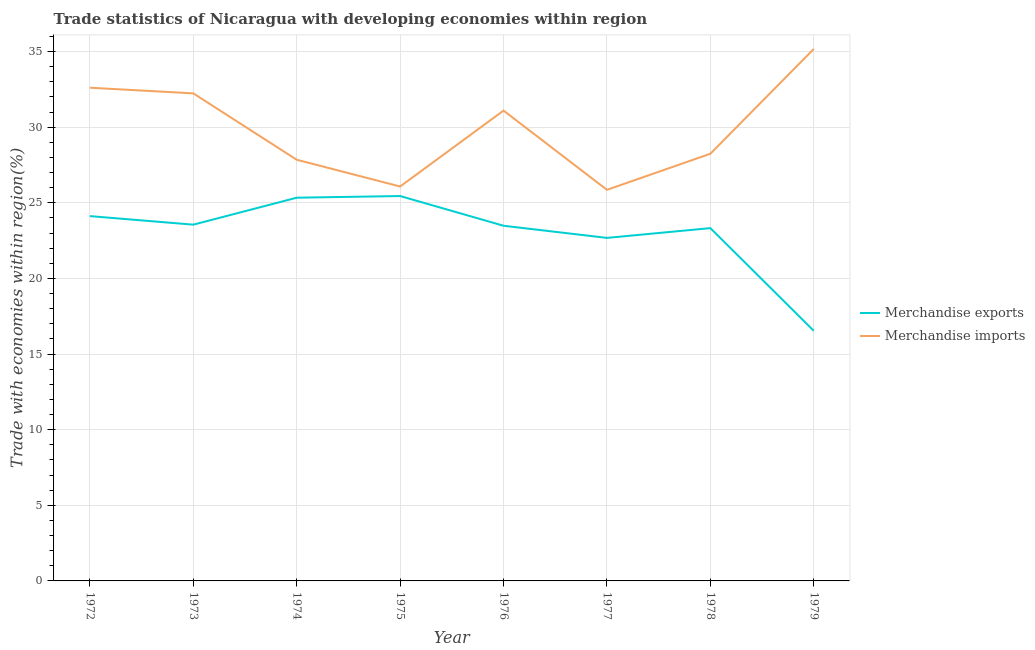Does the line corresponding to merchandise exports intersect with the line corresponding to merchandise imports?
Make the answer very short. No. Is the number of lines equal to the number of legend labels?
Your response must be concise. Yes. What is the merchandise imports in 1977?
Provide a succinct answer. 25.86. Across all years, what is the maximum merchandise imports?
Provide a succinct answer. 35.18. Across all years, what is the minimum merchandise imports?
Offer a terse response. 25.86. In which year was the merchandise imports maximum?
Your answer should be compact. 1979. In which year was the merchandise imports minimum?
Keep it short and to the point. 1977. What is the total merchandise exports in the graph?
Make the answer very short. 184.51. What is the difference between the merchandise exports in 1972 and that in 1976?
Provide a succinct answer. 0.64. What is the difference between the merchandise exports in 1972 and the merchandise imports in 1973?
Your answer should be very brief. -8.12. What is the average merchandise imports per year?
Offer a terse response. 29.9. In the year 1979, what is the difference between the merchandise exports and merchandise imports?
Make the answer very short. -18.64. What is the ratio of the merchandise imports in 1973 to that in 1976?
Offer a terse response. 1.04. What is the difference between the highest and the second highest merchandise imports?
Make the answer very short. 2.56. What is the difference between the highest and the lowest merchandise imports?
Give a very brief answer. 9.31. In how many years, is the merchandise imports greater than the average merchandise imports taken over all years?
Offer a very short reply. 4. Is the sum of the merchandise imports in 1973 and 1979 greater than the maximum merchandise exports across all years?
Keep it short and to the point. Yes. Does the merchandise imports monotonically increase over the years?
Your answer should be very brief. No. Is the merchandise exports strictly greater than the merchandise imports over the years?
Offer a very short reply. No. Are the values on the major ticks of Y-axis written in scientific E-notation?
Make the answer very short. No. Does the graph contain any zero values?
Provide a short and direct response. No. How many legend labels are there?
Give a very brief answer. 2. How are the legend labels stacked?
Keep it short and to the point. Vertical. What is the title of the graph?
Your response must be concise. Trade statistics of Nicaragua with developing economies within region. Does "GDP" appear as one of the legend labels in the graph?
Your answer should be compact. No. What is the label or title of the X-axis?
Offer a very short reply. Year. What is the label or title of the Y-axis?
Provide a succinct answer. Trade with economies within region(%). What is the Trade with economies within region(%) of Merchandise exports in 1972?
Your response must be concise. 24.12. What is the Trade with economies within region(%) of Merchandise imports in 1972?
Give a very brief answer. 32.61. What is the Trade with economies within region(%) of Merchandise exports in 1973?
Provide a succinct answer. 23.56. What is the Trade with economies within region(%) of Merchandise imports in 1973?
Provide a short and direct response. 32.24. What is the Trade with economies within region(%) of Merchandise exports in 1974?
Your response must be concise. 25.34. What is the Trade with economies within region(%) of Merchandise imports in 1974?
Provide a short and direct response. 27.85. What is the Trade with economies within region(%) of Merchandise exports in 1975?
Offer a terse response. 25.45. What is the Trade with economies within region(%) of Merchandise imports in 1975?
Provide a short and direct response. 26.08. What is the Trade with economies within region(%) in Merchandise exports in 1976?
Ensure brevity in your answer.  23.49. What is the Trade with economies within region(%) of Merchandise imports in 1976?
Give a very brief answer. 31.1. What is the Trade with economies within region(%) of Merchandise exports in 1977?
Make the answer very short. 22.68. What is the Trade with economies within region(%) in Merchandise imports in 1977?
Give a very brief answer. 25.86. What is the Trade with economies within region(%) of Merchandise exports in 1978?
Your answer should be very brief. 23.33. What is the Trade with economies within region(%) in Merchandise imports in 1978?
Ensure brevity in your answer.  28.25. What is the Trade with economies within region(%) of Merchandise exports in 1979?
Your answer should be very brief. 16.54. What is the Trade with economies within region(%) of Merchandise imports in 1979?
Ensure brevity in your answer.  35.18. Across all years, what is the maximum Trade with economies within region(%) of Merchandise exports?
Provide a succinct answer. 25.45. Across all years, what is the maximum Trade with economies within region(%) in Merchandise imports?
Ensure brevity in your answer.  35.18. Across all years, what is the minimum Trade with economies within region(%) of Merchandise exports?
Provide a succinct answer. 16.54. Across all years, what is the minimum Trade with economies within region(%) of Merchandise imports?
Offer a terse response. 25.86. What is the total Trade with economies within region(%) of Merchandise exports in the graph?
Your answer should be very brief. 184.51. What is the total Trade with economies within region(%) in Merchandise imports in the graph?
Provide a short and direct response. 239.17. What is the difference between the Trade with economies within region(%) of Merchandise exports in 1972 and that in 1973?
Offer a very short reply. 0.56. What is the difference between the Trade with economies within region(%) in Merchandise imports in 1972 and that in 1973?
Provide a succinct answer. 0.37. What is the difference between the Trade with economies within region(%) of Merchandise exports in 1972 and that in 1974?
Your answer should be compact. -1.22. What is the difference between the Trade with economies within region(%) of Merchandise imports in 1972 and that in 1974?
Keep it short and to the point. 4.76. What is the difference between the Trade with economies within region(%) of Merchandise exports in 1972 and that in 1975?
Your answer should be compact. -1.33. What is the difference between the Trade with economies within region(%) of Merchandise imports in 1972 and that in 1975?
Keep it short and to the point. 6.53. What is the difference between the Trade with economies within region(%) in Merchandise exports in 1972 and that in 1976?
Provide a succinct answer. 0.64. What is the difference between the Trade with economies within region(%) of Merchandise imports in 1972 and that in 1976?
Keep it short and to the point. 1.51. What is the difference between the Trade with economies within region(%) of Merchandise exports in 1972 and that in 1977?
Your answer should be compact. 1.44. What is the difference between the Trade with economies within region(%) of Merchandise imports in 1972 and that in 1977?
Make the answer very short. 6.75. What is the difference between the Trade with economies within region(%) in Merchandise exports in 1972 and that in 1978?
Provide a short and direct response. 0.79. What is the difference between the Trade with economies within region(%) of Merchandise imports in 1972 and that in 1978?
Your answer should be compact. 4.37. What is the difference between the Trade with economies within region(%) of Merchandise exports in 1972 and that in 1979?
Offer a terse response. 7.58. What is the difference between the Trade with economies within region(%) of Merchandise imports in 1972 and that in 1979?
Provide a short and direct response. -2.56. What is the difference between the Trade with economies within region(%) of Merchandise exports in 1973 and that in 1974?
Make the answer very short. -1.78. What is the difference between the Trade with economies within region(%) of Merchandise imports in 1973 and that in 1974?
Provide a short and direct response. 4.39. What is the difference between the Trade with economies within region(%) of Merchandise exports in 1973 and that in 1975?
Provide a short and direct response. -1.89. What is the difference between the Trade with economies within region(%) of Merchandise imports in 1973 and that in 1975?
Give a very brief answer. 6.16. What is the difference between the Trade with economies within region(%) of Merchandise exports in 1973 and that in 1976?
Provide a short and direct response. 0.07. What is the difference between the Trade with economies within region(%) of Merchandise imports in 1973 and that in 1976?
Make the answer very short. 1.14. What is the difference between the Trade with economies within region(%) in Merchandise exports in 1973 and that in 1977?
Keep it short and to the point. 0.88. What is the difference between the Trade with economies within region(%) of Merchandise imports in 1973 and that in 1977?
Provide a short and direct response. 6.38. What is the difference between the Trade with economies within region(%) of Merchandise exports in 1973 and that in 1978?
Provide a succinct answer. 0.23. What is the difference between the Trade with economies within region(%) of Merchandise imports in 1973 and that in 1978?
Give a very brief answer. 3.99. What is the difference between the Trade with economies within region(%) of Merchandise exports in 1973 and that in 1979?
Your answer should be compact. 7.02. What is the difference between the Trade with economies within region(%) of Merchandise imports in 1973 and that in 1979?
Keep it short and to the point. -2.94. What is the difference between the Trade with economies within region(%) in Merchandise exports in 1974 and that in 1975?
Keep it short and to the point. -0.11. What is the difference between the Trade with economies within region(%) in Merchandise imports in 1974 and that in 1975?
Give a very brief answer. 1.77. What is the difference between the Trade with economies within region(%) of Merchandise exports in 1974 and that in 1976?
Provide a short and direct response. 1.85. What is the difference between the Trade with economies within region(%) in Merchandise imports in 1974 and that in 1976?
Offer a very short reply. -3.25. What is the difference between the Trade with economies within region(%) in Merchandise exports in 1974 and that in 1977?
Your answer should be very brief. 2.66. What is the difference between the Trade with economies within region(%) in Merchandise imports in 1974 and that in 1977?
Offer a very short reply. 1.99. What is the difference between the Trade with economies within region(%) in Merchandise exports in 1974 and that in 1978?
Ensure brevity in your answer.  2.01. What is the difference between the Trade with economies within region(%) of Merchandise imports in 1974 and that in 1978?
Offer a terse response. -0.4. What is the difference between the Trade with economies within region(%) in Merchandise exports in 1974 and that in 1979?
Ensure brevity in your answer.  8.8. What is the difference between the Trade with economies within region(%) in Merchandise imports in 1974 and that in 1979?
Provide a succinct answer. -7.33. What is the difference between the Trade with economies within region(%) of Merchandise exports in 1975 and that in 1976?
Your answer should be compact. 1.96. What is the difference between the Trade with economies within region(%) in Merchandise imports in 1975 and that in 1976?
Provide a short and direct response. -5.02. What is the difference between the Trade with economies within region(%) of Merchandise exports in 1975 and that in 1977?
Your answer should be very brief. 2.77. What is the difference between the Trade with economies within region(%) in Merchandise imports in 1975 and that in 1977?
Your answer should be very brief. 0.22. What is the difference between the Trade with economies within region(%) in Merchandise exports in 1975 and that in 1978?
Your answer should be very brief. 2.12. What is the difference between the Trade with economies within region(%) of Merchandise imports in 1975 and that in 1978?
Provide a short and direct response. -2.17. What is the difference between the Trade with economies within region(%) of Merchandise exports in 1975 and that in 1979?
Offer a very short reply. 8.91. What is the difference between the Trade with economies within region(%) in Merchandise imports in 1975 and that in 1979?
Make the answer very short. -9.09. What is the difference between the Trade with economies within region(%) of Merchandise exports in 1976 and that in 1977?
Make the answer very short. 0.8. What is the difference between the Trade with economies within region(%) in Merchandise imports in 1976 and that in 1977?
Give a very brief answer. 5.24. What is the difference between the Trade with economies within region(%) in Merchandise exports in 1976 and that in 1978?
Offer a terse response. 0.16. What is the difference between the Trade with economies within region(%) in Merchandise imports in 1976 and that in 1978?
Offer a very short reply. 2.85. What is the difference between the Trade with economies within region(%) of Merchandise exports in 1976 and that in 1979?
Ensure brevity in your answer.  6.95. What is the difference between the Trade with economies within region(%) of Merchandise imports in 1976 and that in 1979?
Give a very brief answer. -4.08. What is the difference between the Trade with economies within region(%) in Merchandise exports in 1977 and that in 1978?
Keep it short and to the point. -0.65. What is the difference between the Trade with economies within region(%) in Merchandise imports in 1977 and that in 1978?
Offer a very short reply. -2.39. What is the difference between the Trade with economies within region(%) in Merchandise exports in 1977 and that in 1979?
Provide a succinct answer. 6.14. What is the difference between the Trade with economies within region(%) in Merchandise imports in 1977 and that in 1979?
Give a very brief answer. -9.31. What is the difference between the Trade with economies within region(%) of Merchandise exports in 1978 and that in 1979?
Give a very brief answer. 6.79. What is the difference between the Trade with economies within region(%) of Merchandise imports in 1978 and that in 1979?
Your answer should be very brief. -6.93. What is the difference between the Trade with economies within region(%) in Merchandise exports in 1972 and the Trade with economies within region(%) in Merchandise imports in 1973?
Your response must be concise. -8.12. What is the difference between the Trade with economies within region(%) of Merchandise exports in 1972 and the Trade with economies within region(%) of Merchandise imports in 1974?
Your answer should be compact. -3.73. What is the difference between the Trade with economies within region(%) of Merchandise exports in 1972 and the Trade with economies within region(%) of Merchandise imports in 1975?
Make the answer very short. -1.96. What is the difference between the Trade with economies within region(%) of Merchandise exports in 1972 and the Trade with economies within region(%) of Merchandise imports in 1976?
Provide a succinct answer. -6.98. What is the difference between the Trade with economies within region(%) of Merchandise exports in 1972 and the Trade with economies within region(%) of Merchandise imports in 1977?
Your answer should be compact. -1.74. What is the difference between the Trade with economies within region(%) in Merchandise exports in 1972 and the Trade with economies within region(%) in Merchandise imports in 1978?
Your response must be concise. -4.12. What is the difference between the Trade with economies within region(%) of Merchandise exports in 1972 and the Trade with economies within region(%) of Merchandise imports in 1979?
Provide a short and direct response. -11.05. What is the difference between the Trade with economies within region(%) of Merchandise exports in 1973 and the Trade with economies within region(%) of Merchandise imports in 1974?
Provide a succinct answer. -4.29. What is the difference between the Trade with economies within region(%) of Merchandise exports in 1973 and the Trade with economies within region(%) of Merchandise imports in 1975?
Your response must be concise. -2.52. What is the difference between the Trade with economies within region(%) of Merchandise exports in 1973 and the Trade with economies within region(%) of Merchandise imports in 1976?
Provide a succinct answer. -7.54. What is the difference between the Trade with economies within region(%) in Merchandise exports in 1973 and the Trade with economies within region(%) in Merchandise imports in 1977?
Provide a short and direct response. -2.3. What is the difference between the Trade with economies within region(%) of Merchandise exports in 1973 and the Trade with economies within region(%) of Merchandise imports in 1978?
Your answer should be compact. -4.69. What is the difference between the Trade with economies within region(%) of Merchandise exports in 1973 and the Trade with economies within region(%) of Merchandise imports in 1979?
Provide a succinct answer. -11.62. What is the difference between the Trade with economies within region(%) of Merchandise exports in 1974 and the Trade with economies within region(%) of Merchandise imports in 1975?
Your answer should be compact. -0.74. What is the difference between the Trade with economies within region(%) of Merchandise exports in 1974 and the Trade with economies within region(%) of Merchandise imports in 1976?
Provide a succinct answer. -5.76. What is the difference between the Trade with economies within region(%) in Merchandise exports in 1974 and the Trade with economies within region(%) in Merchandise imports in 1977?
Make the answer very short. -0.52. What is the difference between the Trade with economies within region(%) in Merchandise exports in 1974 and the Trade with economies within region(%) in Merchandise imports in 1978?
Offer a terse response. -2.91. What is the difference between the Trade with economies within region(%) of Merchandise exports in 1974 and the Trade with economies within region(%) of Merchandise imports in 1979?
Ensure brevity in your answer.  -9.84. What is the difference between the Trade with economies within region(%) of Merchandise exports in 1975 and the Trade with economies within region(%) of Merchandise imports in 1976?
Your answer should be compact. -5.65. What is the difference between the Trade with economies within region(%) of Merchandise exports in 1975 and the Trade with economies within region(%) of Merchandise imports in 1977?
Your answer should be compact. -0.41. What is the difference between the Trade with economies within region(%) of Merchandise exports in 1975 and the Trade with economies within region(%) of Merchandise imports in 1978?
Ensure brevity in your answer.  -2.8. What is the difference between the Trade with economies within region(%) in Merchandise exports in 1975 and the Trade with economies within region(%) in Merchandise imports in 1979?
Ensure brevity in your answer.  -9.72. What is the difference between the Trade with economies within region(%) of Merchandise exports in 1976 and the Trade with economies within region(%) of Merchandise imports in 1977?
Provide a succinct answer. -2.38. What is the difference between the Trade with economies within region(%) of Merchandise exports in 1976 and the Trade with economies within region(%) of Merchandise imports in 1978?
Your response must be concise. -4.76. What is the difference between the Trade with economies within region(%) of Merchandise exports in 1976 and the Trade with economies within region(%) of Merchandise imports in 1979?
Provide a succinct answer. -11.69. What is the difference between the Trade with economies within region(%) of Merchandise exports in 1977 and the Trade with economies within region(%) of Merchandise imports in 1978?
Keep it short and to the point. -5.56. What is the difference between the Trade with economies within region(%) in Merchandise exports in 1977 and the Trade with economies within region(%) in Merchandise imports in 1979?
Provide a short and direct response. -12.49. What is the difference between the Trade with economies within region(%) of Merchandise exports in 1978 and the Trade with economies within region(%) of Merchandise imports in 1979?
Keep it short and to the point. -11.85. What is the average Trade with economies within region(%) in Merchandise exports per year?
Keep it short and to the point. 23.06. What is the average Trade with economies within region(%) in Merchandise imports per year?
Provide a succinct answer. 29.9. In the year 1972, what is the difference between the Trade with economies within region(%) of Merchandise exports and Trade with economies within region(%) of Merchandise imports?
Keep it short and to the point. -8.49. In the year 1973, what is the difference between the Trade with economies within region(%) in Merchandise exports and Trade with economies within region(%) in Merchandise imports?
Make the answer very short. -8.68. In the year 1974, what is the difference between the Trade with economies within region(%) in Merchandise exports and Trade with economies within region(%) in Merchandise imports?
Your answer should be compact. -2.51. In the year 1975, what is the difference between the Trade with economies within region(%) of Merchandise exports and Trade with economies within region(%) of Merchandise imports?
Ensure brevity in your answer.  -0.63. In the year 1976, what is the difference between the Trade with economies within region(%) in Merchandise exports and Trade with economies within region(%) in Merchandise imports?
Provide a succinct answer. -7.61. In the year 1977, what is the difference between the Trade with economies within region(%) in Merchandise exports and Trade with economies within region(%) in Merchandise imports?
Keep it short and to the point. -3.18. In the year 1978, what is the difference between the Trade with economies within region(%) in Merchandise exports and Trade with economies within region(%) in Merchandise imports?
Ensure brevity in your answer.  -4.92. In the year 1979, what is the difference between the Trade with economies within region(%) in Merchandise exports and Trade with economies within region(%) in Merchandise imports?
Offer a very short reply. -18.64. What is the ratio of the Trade with economies within region(%) in Merchandise imports in 1972 to that in 1973?
Offer a terse response. 1.01. What is the ratio of the Trade with economies within region(%) in Merchandise exports in 1972 to that in 1974?
Your answer should be very brief. 0.95. What is the ratio of the Trade with economies within region(%) in Merchandise imports in 1972 to that in 1974?
Offer a terse response. 1.17. What is the ratio of the Trade with economies within region(%) in Merchandise exports in 1972 to that in 1975?
Keep it short and to the point. 0.95. What is the ratio of the Trade with economies within region(%) of Merchandise imports in 1972 to that in 1975?
Offer a terse response. 1.25. What is the ratio of the Trade with economies within region(%) in Merchandise exports in 1972 to that in 1976?
Give a very brief answer. 1.03. What is the ratio of the Trade with economies within region(%) in Merchandise imports in 1972 to that in 1976?
Offer a very short reply. 1.05. What is the ratio of the Trade with economies within region(%) of Merchandise exports in 1972 to that in 1977?
Provide a succinct answer. 1.06. What is the ratio of the Trade with economies within region(%) in Merchandise imports in 1972 to that in 1977?
Your answer should be very brief. 1.26. What is the ratio of the Trade with economies within region(%) in Merchandise exports in 1972 to that in 1978?
Your answer should be compact. 1.03. What is the ratio of the Trade with economies within region(%) in Merchandise imports in 1972 to that in 1978?
Offer a terse response. 1.15. What is the ratio of the Trade with economies within region(%) in Merchandise exports in 1972 to that in 1979?
Offer a very short reply. 1.46. What is the ratio of the Trade with economies within region(%) in Merchandise imports in 1972 to that in 1979?
Make the answer very short. 0.93. What is the ratio of the Trade with economies within region(%) of Merchandise exports in 1973 to that in 1974?
Ensure brevity in your answer.  0.93. What is the ratio of the Trade with economies within region(%) in Merchandise imports in 1973 to that in 1974?
Your answer should be very brief. 1.16. What is the ratio of the Trade with economies within region(%) in Merchandise exports in 1973 to that in 1975?
Offer a very short reply. 0.93. What is the ratio of the Trade with economies within region(%) of Merchandise imports in 1973 to that in 1975?
Provide a short and direct response. 1.24. What is the ratio of the Trade with economies within region(%) in Merchandise imports in 1973 to that in 1976?
Offer a very short reply. 1.04. What is the ratio of the Trade with economies within region(%) of Merchandise exports in 1973 to that in 1977?
Make the answer very short. 1.04. What is the ratio of the Trade with economies within region(%) in Merchandise imports in 1973 to that in 1977?
Offer a very short reply. 1.25. What is the ratio of the Trade with economies within region(%) of Merchandise exports in 1973 to that in 1978?
Offer a very short reply. 1.01. What is the ratio of the Trade with economies within region(%) in Merchandise imports in 1973 to that in 1978?
Give a very brief answer. 1.14. What is the ratio of the Trade with economies within region(%) in Merchandise exports in 1973 to that in 1979?
Provide a short and direct response. 1.42. What is the ratio of the Trade with economies within region(%) in Merchandise imports in 1973 to that in 1979?
Offer a terse response. 0.92. What is the ratio of the Trade with economies within region(%) of Merchandise exports in 1974 to that in 1975?
Keep it short and to the point. 1. What is the ratio of the Trade with economies within region(%) of Merchandise imports in 1974 to that in 1975?
Make the answer very short. 1.07. What is the ratio of the Trade with economies within region(%) in Merchandise exports in 1974 to that in 1976?
Provide a succinct answer. 1.08. What is the ratio of the Trade with economies within region(%) of Merchandise imports in 1974 to that in 1976?
Your response must be concise. 0.9. What is the ratio of the Trade with economies within region(%) of Merchandise exports in 1974 to that in 1977?
Keep it short and to the point. 1.12. What is the ratio of the Trade with economies within region(%) of Merchandise exports in 1974 to that in 1978?
Provide a succinct answer. 1.09. What is the ratio of the Trade with economies within region(%) in Merchandise imports in 1974 to that in 1978?
Your answer should be very brief. 0.99. What is the ratio of the Trade with economies within region(%) of Merchandise exports in 1974 to that in 1979?
Provide a succinct answer. 1.53. What is the ratio of the Trade with economies within region(%) of Merchandise imports in 1974 to that in 1979?
Keep it short and to the point. 0.79. What is the ratio of the Trade with economies within region(%) of Merchandise exports in 1975 to that in 1976?
Your answer should be compact. 1.08. What is the ratio of the Trade with economies within region(%) of Merchandise imports in 1975 to that in 1976?
Provide a succinct answer. 0.84. What is the ratio of the Trade with economies within region(%) of Merchandise exports in 1975 to that in 1977?
Offer a terse response. 1.12. What is the ratio of the Trade with economies within region(%) in Merchandise imports in 1975 to that in 1977?
Provide a short and direct response. 1.01. What is the ratio of the Trade with economies within region(%) of Merchandise imports in 1975 to that in 1978?
Give a very brief answer. 0.92. What is the ratio of the Trade with economies within region(%) in Merchandise exports in 1975 to that in 1979?
Your answer should be compact. 1.54. What is the ratio of the Trade with economies within region(%) in Merchandise imports in 1975 to that in 1979?
Make the answer very short. 0.74. What is the ratio of the Trade with economies within region(%) of Merchandise exports in 1976 to that in 1977?
Offer a terse response. 1.04. What is the ratio of the Trade with economies within region(%) in Merchandise imports in 1976 to that in 1977?
Offer a very short reply. 1.2. What is the ratio of the Trade with economies within region(%) of Merchandise exports in 1976 to that in 1978?
Give a very brief answer. 1.01. What is the ratio of the Trade with economies within region(%) in Merchandise imports in 1976 to that in 1978?
Make the answer very short. 1.1. What is the ratio of the Trade with economies within region(%) in Merchandise exports in 1976 to that in 1979?
Offer a terse response. 1.42. What is the ratio of the Trade with economies within region(%) of Merchandise imports in 1976 to that in 1979?
Give a very brief answer. 0.88. What is the ratio of the Trade with economies within region(%) of Merchandise exports in 1977 to that in 1978?
Give a very brief answer. 0.97. What is the ratio of the Trade with economies within region(%) in Merchandise imports in 1977 to that in 1978?
Keep it short and to the point. 0.92. What is the ratio of the Trade with economies within region(%) of Merchandise exports in 1977 to that in 1979?
Your answer should be very brief. 1.37. What is the ratio of the Trade with economies within region(%) in Merchandise imports in 1977 to that in 1979?
Your response must be concise. 0.74. What is the ratio of the Trade with economies within region(%) of Merchandise exports in 1978 to that in 1979?
Provide a succinct answer. 1.41. What is the ratio of the Trade with economies within region(%) in Merchandise imports in 1978 to that in 1979?
Your response must be concise. 0.8. What is the difference between the highest and the second highest Trade with economies within region(%) of Merchandise exports?
Ensure brevity in your answer.  0.11. What is the difference between the highest and the second highest Trade with economies within region(%) in Merchandise imports?
Your answer should be very brief. 2.56. What is the difference between the highest and the lowest Trade with economies within region(%) of Merchandise exports?
Your answer should be compact. 8.91. What is the difference between the highest and the lowest Trade with economies within region(%) in Merchandise imports?
Keep it short and to the point. 9.31. 